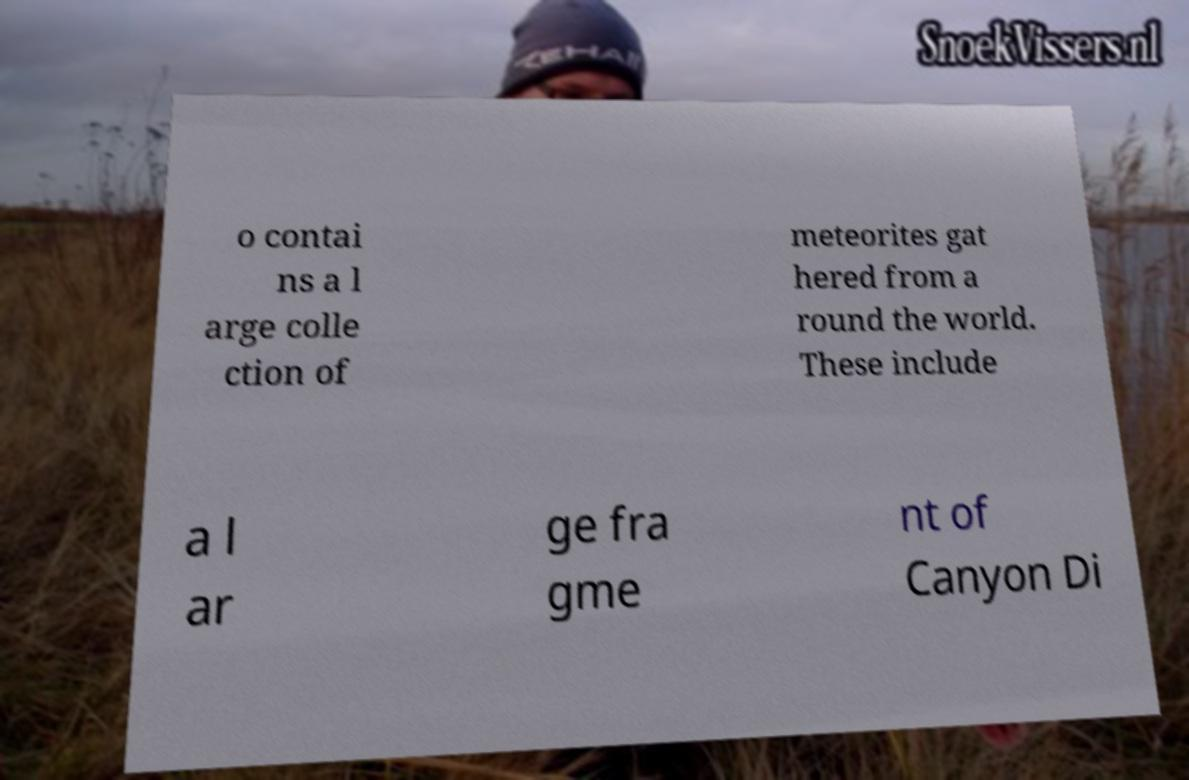For documentation purposes, I need the text within this image transcribed. Could you provide that? o contai ns a l arge colle ction of meteorites gat hered from a round the world. These include a l ar ge fra gme nt of Canyon Di 